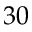<formula> <loc_0><loc_0><loc_500><loc_500>3 0</formula> 